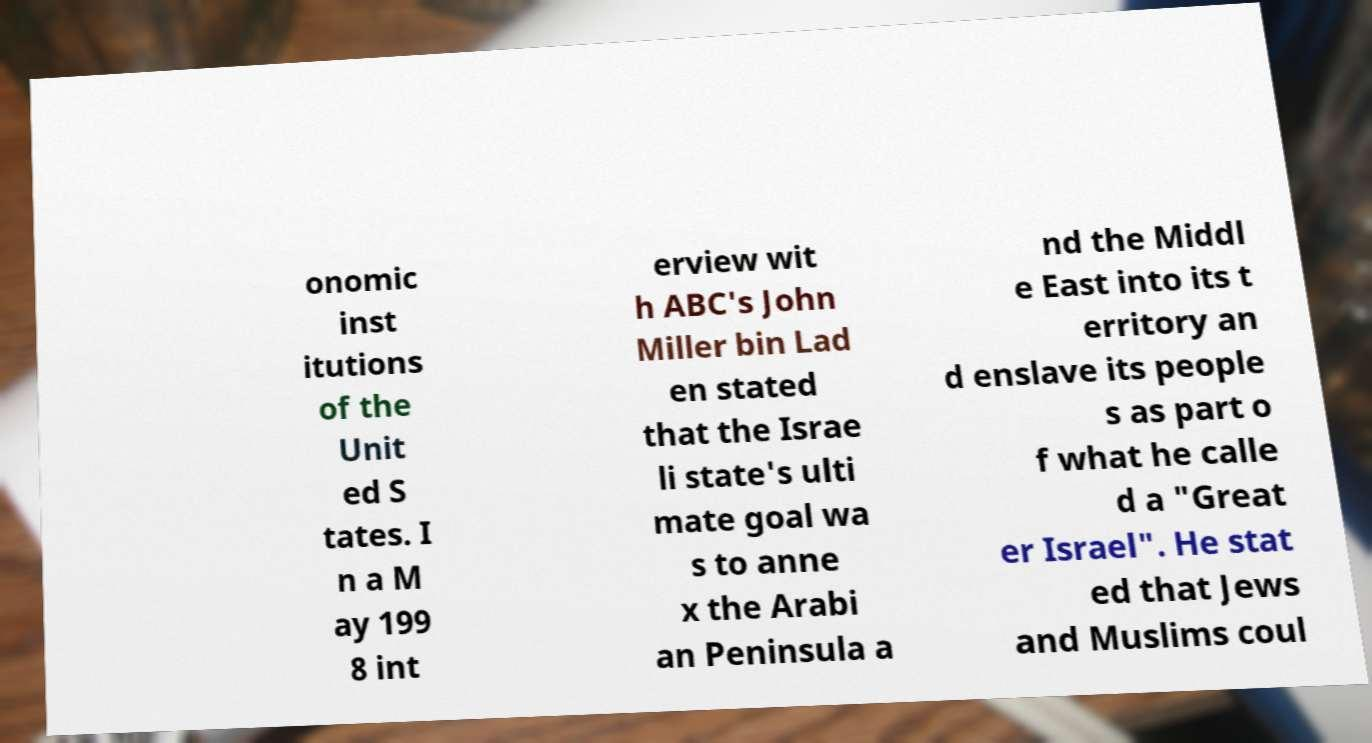Please identify and transcribe the text found in this image. onomic inst itutions of the Unit ed S tates. I n a M ay 199 8 int erview wit h ABC's John Miller bin Lad en stated that the Israe li state's ulti mate goal wa s to anne x the Arabi an Peninsula a nd the Middl e East into its t erritory an d enslave its people s as part o f what he calle d a "Great er Israel". He stat ed that Jews and Muslims coul 